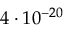<formula> <loc_0><loc_0><loc_500><loc_500>4 \cdot 1 0 ^ { - 2 0 }</formula> 